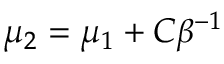<formula> <loc_0><loc_0><loc_500><loc_500>\mu _ { 2 } = \mu _ { 1 } + C \beta ^ { - 1 }</formula> 